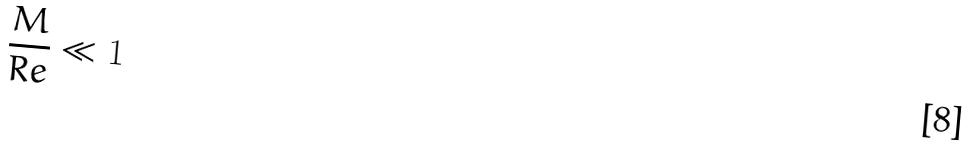<formula> <loc_0><loc_0><loc_500><loc_500>\frac { M } { R e } \ll 1</formula> 